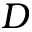Convert formula to latex. <formula><loc_0><loc_0><loc_500><loc_500>D</formula> 